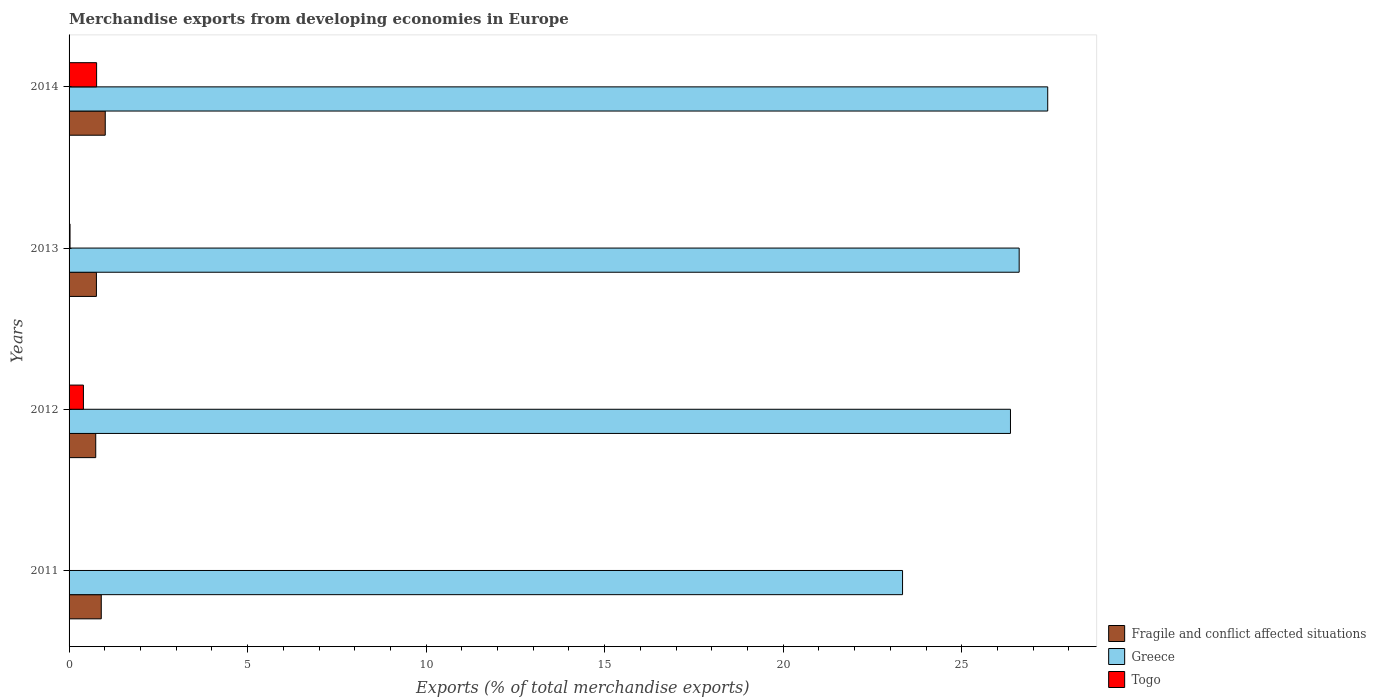How many different coloured bars are there?
Make the answer very short. 3. Are the number of bars on each tick of the Y-axis equal?
Provide a succinct answer. Yes. In how many cases, is the number of bars for a given year not equal to the number of legend labels?
Offer a terse response. 0. What is the percentage of total merchandise exports in Greece in 2014?
Provide a succinct answer. 27.41. Across all years, what is the maximum percentage of total merchandise exports in Greece?
Provide a short and direct response. 27.41. Across all years, what is the minimum percentage of total merchandise exports in Togo?
Offer a terse response. 0. In which year was the percentage of total merchandise exports in Greece maximum?
Your answer should be compact. 2014. What is the total percentage of total merchandise exports in Greece in the graph?
Offer a terse response. 103.72. What is the difference between the percentage of total merchandise exports in Togo in 2011 and that in 2013?
Give a very brief answer. -0.03. What is the difference between the percentage of total merchandise exports in Fragile and conflict affected situations in 2011 and the percentage of total merchandise exports in Greece in 2013?
Keep it short and to the point. -25.71. What is the average percentage of total merchandise exports in Togo per year?
Offer a terse response. 0.3. In the year 2014, what is the difference between the percentage of total merchandise exports in Togo and percentage of total merchandise exports in Fragile and conflict affected situations?
Offer a terse response. -0.24. What is the ratio of the percentage of total merchandise exports in Togo in 2011 to that in 2014?
Offer a very short reply. 0. What is the difference between the highest and the second highest percentage of total merchandise exports in Togo?
Your answer should be very brief. 0.37. What is the difference between the highest and the lowest percentage of total merchandise exports in Togo?
Provide a succinct answer. 0.77. In how many years, is the percentage of total merchandise exports in Togo greater than the average percentage of total merchandise exports in Togo taken over all years?
Keep it short and to the point. 2. Is the sum of the percentage of total merchandise exports in Fragile and conflict affected situations in 2011 and 2014 greater than the maximum percentage of total merchandise exports in Greece across all years?
Keep it short and to the point. No. What does the 1st bar from the top in 2013 represents?
Your answer should be very brief. Togo. What does the 2nd bar from the bottom in 2013 represents?
Your answer should be compact. Greece. Are all the bars in the graph horizontal?
Offer a terse response. Yes. What is the difference between two consecutive major ticks on the X-axis?
Give a very brief answer. 5. Does the graph contain any zero values?
Give a very brief answer. No. Does the graph contain grids?
Provide a succinct answer. No. Where does the legend appear in the graph?
Provide a succinct answer. Bottom right. What is the title of the graph?
Offer a very short reply. Merchandise exports from developing economies in Europe. Does "Solomon Islands" appear as one of the legend labels in the graph?
Provide a succinct answer. No. What is the label or title of the X-axis?
Your answer should be very brief. Exports (% of total merchandise exports). What is the label or title of the Y-axis?
Ensure brevity in your answer.  Years. What is the Exports (% of total merchandise exports) of Fragile and conflict affected situations in 2011?
Ensure brevity in your answer.  0.9. What is the Exports (% of total merchandise exports) of Greece in 2011?
Give a very brief answer. 23.34. What is the Exports (% of total merchandise exports) of Togo in 2011?
Give a very brief answer. 0. What is the Exports (% of total merchandise exports) of Fragile and conflict affected situations in 2012?
Your response must be concise. 0.75. What is the Exports (% of total merchandise exports) of Greece in 2012?
Keep it short and to the point. 26.36. What is the Exports (% of total merchandise exports) of Togo in 2012?
Your answer should be very brief. 0.4. What is the Exports (% of total merchandise exports) of Fragile and conflict affected situations in 2013?
Ensure brevity in your answer.  0.77. What is the Exports (% of total merchandise exports) of Greece in 2013?
Ensure brevity in your answer.  26.61. What is the Exports (% of total merchandise exports) in Togo in 2013?
Provide a short and direct response. 0.03. What is the Exports (% of total merchandise exports) in Fragile and conflict affected situations in 2014?
Provide a succinct answer. 1.01. What is the Exports (% of total merchandise exports) in Greece in 2014?
Make the answer very short. 27.41. What is the Exports (% of total merchandise exports) of Togo in 2014?
Your response must be concise. 0.77. Across all years, what is the maximum Exports (% of total merchandise exports) in Fragile and conflict affected situations?
Your response must be concise. 1.01. Across all years, what is the maximum Exports (% of total merchandise exports) of Greece?
Your answer should be compact. 27.41. Across all years, what is the maximum Exports (% of total merchandise exports) of Togo?
Your answer should be compact. 0.77. Across all years, what is the minimum Exports (% of total merchandise exports) of Fragile and conflict affected situations?
Your answer should be compact. 0.75. Across all years, what is the minimum Exports (% of total merchandise exports) in Greece?
Provide a succinct answer. 23.34. Across all years, what is the minimum Exports (% of total merchandise exports) of Togo?
Give a very brief answer. 0. What is the total Exports (% of total merchandise exports) of Fragile and conflict affected situations in the graph?
Offer a terse response. 3.43. What is the total Exports (% of total merchandise exports) in Greece in the graph?
Provide a succinct answer. 103.72. What is the total Exports (% of total merchandise exports) of Togo in the graph?
Your answer should be very brief. 1.2. What is the difference between the Exports (% of total merchandise exports) of Fragile and conflict affected situations in 2011 and that in 2012?
Your answer should be compact. 0.15. What is the difference between the Exports (% of total merchandise exports) in Greece in 2011 and that in 2012?
Your response must be concise. -3.02. What is the difference between the Exports (% of total merchandise exports) in Togo in 2011 and that in 2012?
Keep it short and to the point. -0.4. What is the difference between the Exports (% of total merchandise exports) in Fragile and conflict affected situations in 2011 and that in 2013?
Make the answer very short. 0.14. What is the difference between the Exports (% of total merchandise exports) in Greece in 2011 and that in 2013?
Give a very brief answer. -3.27. What is the difference between the Exports (% of total merchandise exports) of Togo in 2011 and that in 2013?
Offer a terse response. -0.03. What is the difference between the Exports (% of total merchandise exports) in Fragile and conflict affected situations in 2011 and that in 2014?
Offer a very short reply. -0.11. What is the difference between the Exports (% of total merchandise exports) of Greece in 2011 and that in 2014?
Offer a very short reply. -4.07. What is the difference between the Exports (% of total merchandise exports) in Togo in 2011 and that in 2014?
Keep it short and to the point. -0.77. What is the difference between the Exports (% of total merchandise exports) in Fragile and conflict affected situations in 2012 and that in 2013?
Your answer should be very brief. -0.02. What is the difference between the Exports (% of total merchandise exports) in Greece in 2012 and that in 2013?
Offer a terse response. -0.24. What is the difference between the Exports (% of total merchandise exports) in Togo in 2012 and that in 2013?
Ensure brevity in your answer.  0.38. What is the difference between the Exports (% of total merchandise exports) of Fragile and conflict affected situations in 2012 and that in 2014?
Provide a succinct answer. -0.27. What is the difference between the Exports (% of total merchandise exports) of Greece in 2012 and that in 2014?
Provide a short and direct response. -1.04. What is the difference between the Exports (% of total merchandise exports) in Togo in 2012 and that in 2014?
Your answer should be compact. -0.37. What is the difference between the Exports (% of total merchandise exports) of Fragile and conflict affected situations in 2013 and that in 2014?
Make the answer very short. -0.25. What is the difference between the Exports (% of total merchandise exports) of Greece in 2013 and that in 2014?
Keep it short and to the point. -0.8. What is the difference between the Exports (% of total merchandise exports) of Togo in 2013 and that in 2014?
Offer a very short reply. -0.74. What is the difference between the Exports (% of total merchandise exports) of Fragile and conflict affected situations in 2011 and the Exports (% of total merchandise exports) of Greece in 2012?
Make the answer very short. -25.46. What is the difference between the Exports (% of total merchandise exports) of Fragile and conflict affected situations in 2011 and the Exports (% of total merchandise exports) of Togo in 2012?
Make the answer very short. 0.5. What is the difference between the Exports (% of total merchandise exports) in Greece in 2011 and the Exports (% of total merchandise exports) in Togo in 2012?
Keep it short and to the point. 22.94. What is the difference between the Exports (% of total merchandise exports) of Fragile and conflict affected situations in 2011 and the Exports (% of total merchandise exports) of Greece in 2013?
Your response must be concise. -25.71. What is the difference between the Exports (% of total merchandise exports) in Fragile and conflict affected situations in 2011 and the Exports (% of total merchandise exports) in Togo in 2013?
Your answer should be compact. 0.87. What is the difference between the Exports (% of total merchandise exports) of Greece in 2011 and the Exports (% of total merchandise exports) of Togo in 2013?
Make the answer very short. 23.32. What is the difference between the Exports (% of total merchandise exports) of Fragile and conflict affected situations in 2011 and the Exports (% of total merchandise exports) of Greece in 2014?
Offer a very short reply. -26.51. What is the difference between the Exports (% of total merchandise exports) of Fragile and conflict affected situations in 2011 and the Exports (% of total merchandise exports) of Togo in 2014?
Ensure brevity in your answer.  0.13. What is the difference between the Exports (% of total merchandise exports) in Greece in 2011 and the Exports (% of total merchandise exports) in Togo in 2014?
Offer a terse response. 22.57. What is the difference between the Exports (% of total merchandise exports) of Fragile and conflict affected situations in 2012 and the Exports (% of total merchandise exports) of Greece in 2013?
Keep it short and to the point. -25.86. What is the difference between the Exports (% of total merchandise exports) of Fragile and conflict affected situations in 2012 and the Exports (% of total merchandise exports) of Togo in 2013?
Your answer should be very brief. 0.72. What is the difference between the Exports (% of total merchandise exports) in Greece in 2012 and the Exports (% of total merchandise exports) in Togo in 2013?
Ensure brevity in your answer.  26.34. What is the difference between the Exports (% of total merchandise exports) in Fragile and conflict affected situations in 2012 and the Exports (% of total merchandise exports) in Greece in 2014?
Give a very brief answer. -26.66. What is the difference between the Exports (% of total merchandise exports) in Fragile and conflict affected situations in 2012 and the Exports (% of total merchandise exports) in Togo in 2014?
Provide a short and direct response. -0.02. What is the difference between the Exports (% of total merchandise exports) of Greece in 2012 and the Exports (% of total merchandise exports) of Togo in 2014?
Your answer should be compact. 25.59. What is the difference between the Exports (% of total merchandise exports) of Fragile and conflict affected situations in 2013 and the Exports (% of total merchandise exports) of Greece in 2014?
Offer a terse response. -26.64. What is the difference between the Exports (% of total merchandise exports) in Fragile and conflict affected situations in 2013 and the Exports (% of total merchandise exports) in Togo in 2014?
Your response must be concise. -0.01. What is the difference between the Exports (% of total merchandise exports) of Greece in 2013 and the Exports (% of total merchandise exports) of Togo in 2014?
Keep it short and to the point. 25.84. What is the average Exports (% of total merchandise exports) in Fragile and conflict affected situations per year?
Your answer should be compact. 0.86. What is the average Exports (% of total merchandise exports) in Greece per year?
Provide a succinct answer. 25.93. What is the average Exports (% of total merchandise exports) in Togo per year?
Provide a short and direct response. 0.3. In the year 2011, what is the difference between the Exports (% of total merchandise exports) of Fragile and conflict affected situations and Exports (% of total merchandise exports) of Greece?
Offer a terse response. -22.44. In the year 2011, what is the difference between the Exports (% of total merchandise exports) of Fragile and conflict affected situations and Exports (% of total merchandise exports) of Togo?
Provide a succinct answer. 0.9. In the year 2011, what is the difference between the Exports (% of total merchandise exports) of Greece and Exports (% of total merchandise exports) of Togo?
Provide a short and direct response. 23.34. In the year 2012, what is the difference between the Exports (% of total merchandise exports) in Fragile and conflict affected situations and Exports (% of total merchandise exports) in Greece?
Provide a short and direct response. -25.62. In the year 2012, what is the difference between the Exports (% of total merchandise exports) in Fragile and conflict affected situations and Exports (% of total merchandise exports) in Togo?
Make the answer very short. 0.34. In the year 2012, what is the difference between the Exports (% of total merchandise exports) in Greece and Exports (% of total merchandise exports) in Togo?
Offer a very short reply. 25.96. In the year 2013, what is the difference between the Exports (% of total merchandise exports) in Fragile and conflict affected situations and Exports (% of total merchandise exports) in Greece?
Offer a terse response. -25.84. In the year 2013, what is the difference between the Exports (% of total merchandise exports) of Fragile and conflict affected situations and Exports (% of total merchandise exports) of Togo?
Provide a succinct answer. 0.74. In the year 2013, what is the difference between the Exports (% of total merchandise exports) in Greece and Exports (% of total merchandise exports) in Togo?
Make the answer very short. 26.58. In the year 2014, what is the difference between the Exports (% of total merchandise exports) of Fragile and conflict affected situations and Exports (% of total merchandise exports) of Greece?
Your answer should be very brief. -26.39. In the year 2014, what is the difference between the Exports (% of total merchandise exports) in Fragile and conflict affected situations and Exports (% of total merchandise exports) in Togo?
Offer a very short reply. 0.24. In the year 2014, what is the difference between the Exports (% of total merchandise exports) in Greece and Exports (% of total merchandise exports) in Togo?
Offer a very short reply. 26.64. What is the ratio of the Exports (% of total merchandise exports) of Fragile and conflict affected situations in 2011 to that in 2012?
Give a very brief answer. 1.21. What is the ratio of the Exports (% of total merchandise exports) in Greece in 2011 to that in 2012?
Offer a very short reply. 0.89. What is the ratio of the Exports (% of total merchandise exports) in Togo in 2011 to that in 2012?
Ensure brevity in your answer.  0. What is the ratio of the Exports (% of total merchandise exports) of Fragile and conflict affected situations in 2011 to that in 2013?
Provide a short and direct response. 1.18. What is the ratio of the Exports (% of total merchandise exports) of Greece in 2011 to that in 2013?
Your response must be concise. 0.88. What is the ratio of the Exports (% of total merchandise exports) of Togo in 2011 to that in 2013?
Ensure brevity in your answer.  0.06. What is the ratio of the Exports (% of total merchandise exports) in Fragile and conflict affected situations in 2011 to that in 2014?
Provide a short and direct response. 0.89. What is the ratio of the Exports (% of total merchandise exports) in Greece in 2011 to that in 2014?
Offer a terse response. 0.85. What is the ratio of the Exports (% of total merchandise exports) of Togo in 2011 to that in 2014?
Your response must be concise. 0. What is the ratio of the Exports (% of total merchandise exports) of Fragile and conflict affected situations in 2012 to that in 2013?
Your response must be concise. 0.97. What is the ratio of the Exports (% of total merchandise exports) of Togo in 2012 to that in 2013?
Give a very brief answer. 14.95. What is the ratio of the Exports (% of total merchandise exports) in Fragile and conflict affected situations in 2012 to that in 2014?
Provide a short and direct response. 0.74. What is the ratio of the Exports (% of total merchandise exports) in Greece in 2012 to that in 2014?
Keep it short and to the point. 0.96. What is the ratio of the Exports (% of total merchandise exports) in Togo in 2012 to that in 2014?
Provide a short and direct response. 0.52. What is the ratio of the Exports (% of total merchandise exports) of Fragile and conflict affected situations in 2013 to that in 2014?
Your answer should be compact. 0.76. What is the ratio of the Exports (% of total merchandise exports) of Greece in 2013 to that in 2014?
Provide a short and direct response. 0.97. What is the ratio of the Exports (% of total merchandise exports) in Togo in 2013 to that in 2014?
Your answer should be very brief. 0.03. What is the difference between the highest and the second highest Exports (% of total merchandise exports) of Fragile and conflict affected situations?
Offer a terse response. 0.11. What is the difference between the highest and the second highest Exports (% of total merchandise exports) in Greece?
Make the answer very short. 0.8. What is the difference between the highest and the second highest Exports (% of total merchandise exports) in Togo?
Your answer should be very brief. 0.37. What is the difference between the highest and the lowest Exports (% of total merchandise exports) in Fragile and conflict affected situations?
Ensure brevity in your answer.  0.27. What is the difference between the highest and the lowest Exports (% of total merchandise exports) of Greece?
Your answer should be very brief. 4.07. What is the difference between the highest and the lowest Exports (% of total merchandise exports) of Togo?
Your response must be concise. 0.77. 